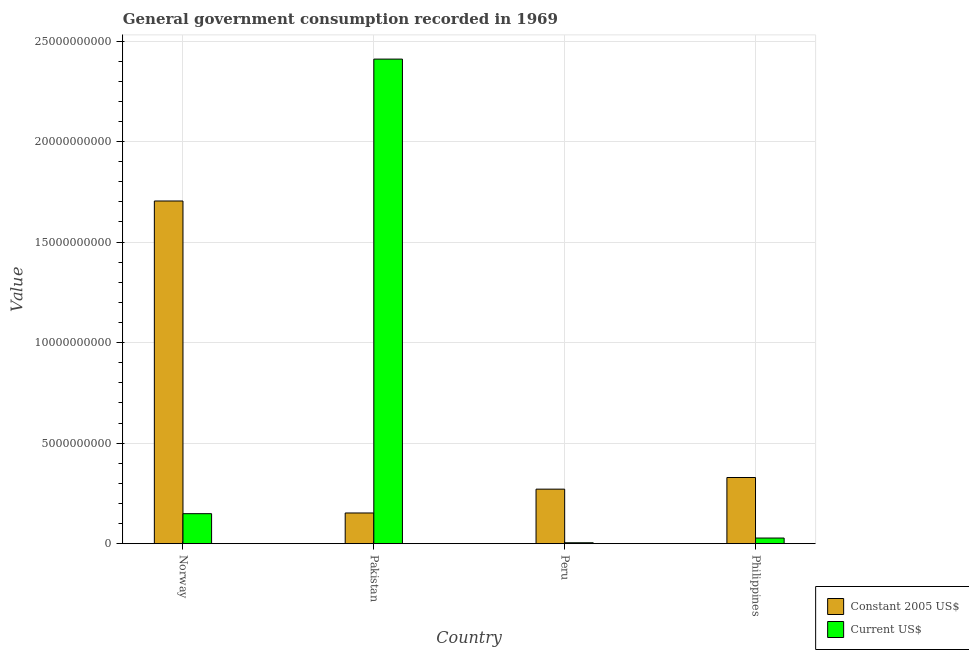What is the value consumed in current us$ in Philippines?
Ensure brevity in your answer.  2.79e+08. Across all countries, what is the maximum value consumed in current us$?
Ensure brevity in your answer.  2.41e+1. Across all countries, what is the minimum value consumed in current us$?
Offer a very short reply. 4.46e+07. In which country was the value consumed in current us$ minimum?
Provide a short and direct response. Peru. What is the total value consumed in current us$ in the graph?
Give a very brief answer. 2.59e+1. What is the difference between the value consumed in current us$ in Pakistan and that in Peru?
Offer a very short reply. 2.41e+1. What is the difference between the value consumed in current us$ in Peru and the value consumed in constant 2005 us$ in Philippines?
Offer a terse response. -3.25e+09. What is the average value consumed in current us$ per country?
Offer a very short reply. 6.48e+09. What is the difference between the value consumed in current us$ and value consumed in constant 2005 us$ in Pakistan?
Give a very brief answer. 2.26e+1. What is the ratio of the value consumed in current us$ in Norway to that in Pakistan?
Your response must be concise. 0.06. Is the value consumed in constant 2005 us$ in Peru less than that in Philippines?
Keep it short and to the point. Yes. What is the difference between the highest and the second highest value consumed in current us$?
Your answer should be compact. 2.26e+1. What is the difference between the highest and the lowest value consumed in constant 2005 us$?
Your response must be concise. 1.55e+1. In how many countries, is the value consumed in current us$ greater than the average value consumed in current us$ taken over all countries?
Offer a very short reply. 1. Is the sum of the value consumed in current us$ in Pakistan and Philippines greater than the maximum value consumed in constant 2005 us$ across all countries?
Your answer should be very brief. Yes. What does the 1st bar from the left in Peru represents?
Keep it short and to the point. Constant 2005 US$. What does the 1st bar from the right in Norway represents?
Your answer should be compact. Current US$. Are all the bars in the graph horizontal?
Your answer should be compact. No. How many countries are there in the graph?
Make the answer very short. 4. What is the difference between two consecutive major ticks on the Y-axis?
Keep it short and to the point. 5.00e+09. Are the values on the major ticks of Y-axis written in scientific E-notation?
Ensure brevity in your answer.  No. Does the graph contain grids?
Your response must be concise. Yes. How are the legend labels stacked?
Make the answer very short. Vertical. What is the title of the graph?
Your answer should be very brief. General government consumption recorded in 1969. Does "Male labourers" appear as one of the legend labels in the graph?
Keep it short and to the point. No. What is the label or title of the Y-axis?
Your response must be concise. Value. What is the Value of Constant 2005 US$ in Norway?
Your response must be concise. 1.70e+1. What is the Value of Current US$ in Norway?
Give a very brief answer. 1.49e+09. What is the Value of Constant 2005 US$ in Pakistan?
Your answer should be compact. 1.53e+09. What is the Value of Current US$ in Pakistan?
Your answer should be compact. 2.41e+1. What is the Value of Constant 2005 US$ in Peru?
Your answer should be compact. 2.71e+09. What is the Value in Current US$ in Peru?
Offer a terse response. 4.46e+07. What is the Value in Constant 2005 US$ in Philippines?
Make the answer very short. 3.29e+09. What is the Value of Current US$ in Philippines?
Make the answer very short. 2.79e+08. Across all countries, what is the maximum Value of Constant 2005 US$?
Give a very brief answer. 1.70e+1. Across all countries, what is the maximum Value of Current US$?
Ensure brevity in your answer.  2.41e+1. Across all countries, what is the minimum Value of Constant 2005 US$?
Your response must be concise. 1.53e+09. Across all countries, what is the minimum Value in Current US$?
Ensure brevity in your answer.  4.46e+07. What is the total Value in Constant 2005 US$ in the graph?
Give a very brief answer. 2.46e+1. What is the total Value of Current US$ in the graph?
Give a very brief answer. 2.59e+1. What is the difference between the Value of Constant 2005 US$ in Norway and that in Pakistan?
Offer a terse response. 1.55e+1. What is the difference between the Value of Current US$ in Norway and that in Pakistan?
Keep it short and to the point. -2.26e+1. What is the difference between the Value of Constant 2005 US$ in Norway and that in Peru?
Provide a succinct answer. 1.43e+1. What is the difference between the Value in Current US$ in Norway and that in Peru?
Offer a very short reply. 1.45e+09. What is the difference between the Value of Constant 2005 US$ in Norway and that in Philippines?
Offer a very short reply. 1.38e+1. What is the difference between the Value in Current US$ in Norway and that in Philippines?
Ensure brevity in your answer.  1.21e+09. What is the difference between the Value in Constant 2005 US$ in Pakistan and that in Peru?
Keep it short and to the point. -1.19e+09. What is the difference between the Value of Current US$ in Pakistan and that in Peru?
Give a very brief answer. 2.41e+1. What is the difference between the Value in Constant 2005 US$ in Pakistan and that in Philippines?
Offer a terse response. -1.76e+09. What is the difference between the Value in Current US$ in Pakistan and that in Philippines?
Your response must be concise. 2.38e+1. What is the difference between the Value in Constant 2005 US$ in Peru and that in Philippines?
Ensure brevity in your answer.  -5.79e+08. What is the difference between the Value in Current US$ in Peru and that in Philippines?
Your answer should be very brief. -2.35e+08. What is the difference between the Value in Constant 2005 US$ in Norway and the Value in Current US$ in Pakistan?
Your answer should be very brief. -7.06e+09. What is the difference between the Value of Constant 2005 US$ in Norway and the Value of Current US$ in Peru?
Provide a short and direct response. 1.70e+1. What is the difference between the Value in Constant 2005 US$ in Norway and the Value in Current US$ in Philippines?
Keep it short and to the point. 1.68e+1. What is the difference between the Value in Constant 2005 US$ in Pakistan and the Value in Current US$ in Peru?
Your answer should be compact. 1.48e+09. What is the difference between the Value in Constant 2005 US$ in Pakistan and the Value in Current US$ in Philippines?
Offer a terse response. 1.25e+09. What is the difference between the Value in Constant 2005 US$ in Peru and the Value in Current US$ in Philippines?
Offer a terse response. 2.43e+09. What is the average Value in Constant 2005 US$ per country?
Offer a very short reply. 6.14e+09. What is the average Value of Current US$ per country?
Ensure brevity in your answer.  6.48e+09. What is the difference between the Value of Constant 2005 US$ and Value of Current US$ in Norway?
Your answer should be very brief. 1.56e+1. What is the difference between the Value in Constant 2005 US$ and Value in Current US$ in Pakistan?
Give a very brief answer. -2.26e+1. What is the difference between the Value in Constant 2005 US$ and Value in Current US$ in Peru?
Provide a short and direct response. 2.67e+09. What is the difference between the Value of Constant 2005 US$ and Value of Current US$ in Philippines?
Your response must be concise. 3.01e+09. What is the ratio of the Value of Constant 2005 US$ in Norway to that in Pakistan?
Your answer should be compact. 11.17. What is the ratio of the Value in Current US$ in Norway to that in Pakistan?
Provide a short and direct response. 0.06. What is the ratio of the Value in Constant 2005 US$ in Norway to that in Peru?
Provide a short and direct response. 6.29. What is the ratio of the Value in Current US$ in Norway to that in Peru?
Offer a very short reply. 33.41. What is the ratio of the Value of Constant 2005 US$ in Norway to that in Philippines?
Keep it short and to the point. 5.18. What is the ratio of the Value of Current US$ in Norway to that in Philippines?
Give a very brief answer. 5.33. What is the ratio of the Value in Constant 2005 US$ in Pakistan to that in Peru?
Your answer should be compact. 0.56. What is the ratio of the Value of Current US$ in Pakistan to that in Peru?
Make the answer very short. 540.11. What is the ratio of the Value of Constant 2005 US$ in Pakistan to that in Philippines?
Make the answer very short. 0.46. What is the ratio of the Value in Current US$ in Pakistan to that in Philippines?
Provide a short and direct response. 86.24. What is the ratio of the Value of Constant 2005 US$ in Peru to that in Philippines?
Your answer should be very brief. 0.82. What is the ratio of the Value of Current US$ in Peru to that in Philippines?
Offer a terse response. 0.16. What is the difference between the highest and the second highest Value of Constant 2005 US$?
Offer a terse response. 1.38e+1. What is the difference between the highest and the second highest Value of Current US$?
Provide a short and direct response. 2.26e+1. What is the difference between the highest and the lowest Value of Constant 2005 US$?
Give a very brief answer. 1.55e+1. What is the difference between the highest and the lowest Value in Current US$?
Ensure brevity in your answer.  2.41e+1. 